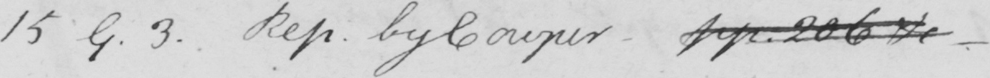Can you read and transcribe this handwriting? 15 9 . 3 . Rep . by Cowper  _  pp . 206 &  _ 